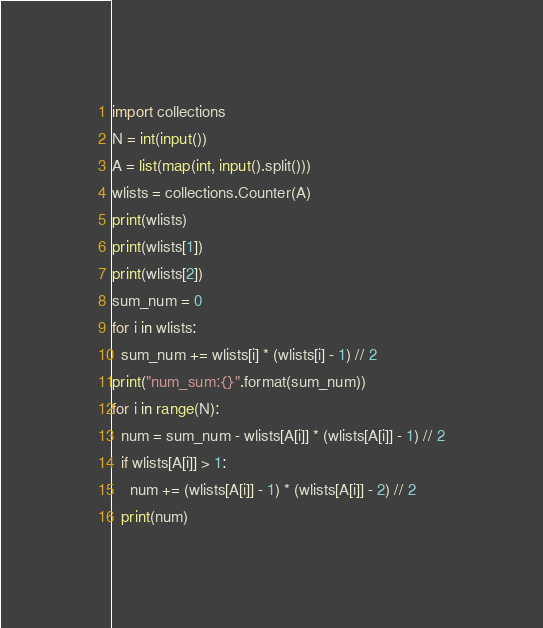Convert code to text. <code><loc_0><loc_0><loc_500><loc_500><_Python_>import collections
N = int(input())
A = list(map(int, input().split()))
wlists = collections.Counter(A)
print(wlists)
print(wlists[1])
print(wlists[2])
sum_num = 0
for i in wlists:
  sum_num += wlists[i] * (wlists[i] - 1) // 2
print("num_sum:{}".format(sum_num))
for i in range(N):
  num = sum_num - wlists[A[i]] * (wlists[A[i]] - 1) // 2
  if wlists[A[i]] > 1:
    num += (wlists[A[i]] - 1) * (wlists[A[i]] - 2) // 2
  print(num)</code> 